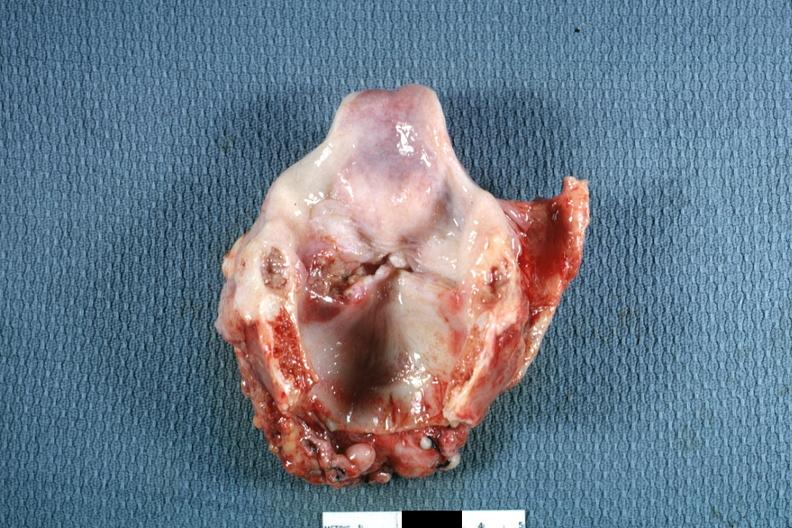where is this?
Answer the question using a single word or phrase. Oral 